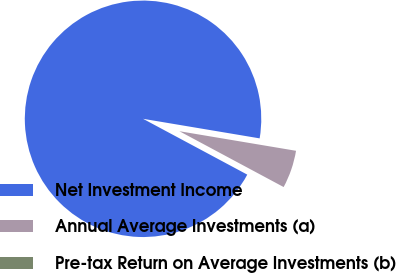Convert chart to OTSL. <chart><loc_0><loc_0><loc_500><loc_500><pie_chart><fcel>Net Investment Income<fcel>Annual Average Investments (a)<fcel>Pre-tax Return on Average Investments (b)<nl><fcel>94.82%<fcel>5.18%<fcel>0.0%<nl></chart> 